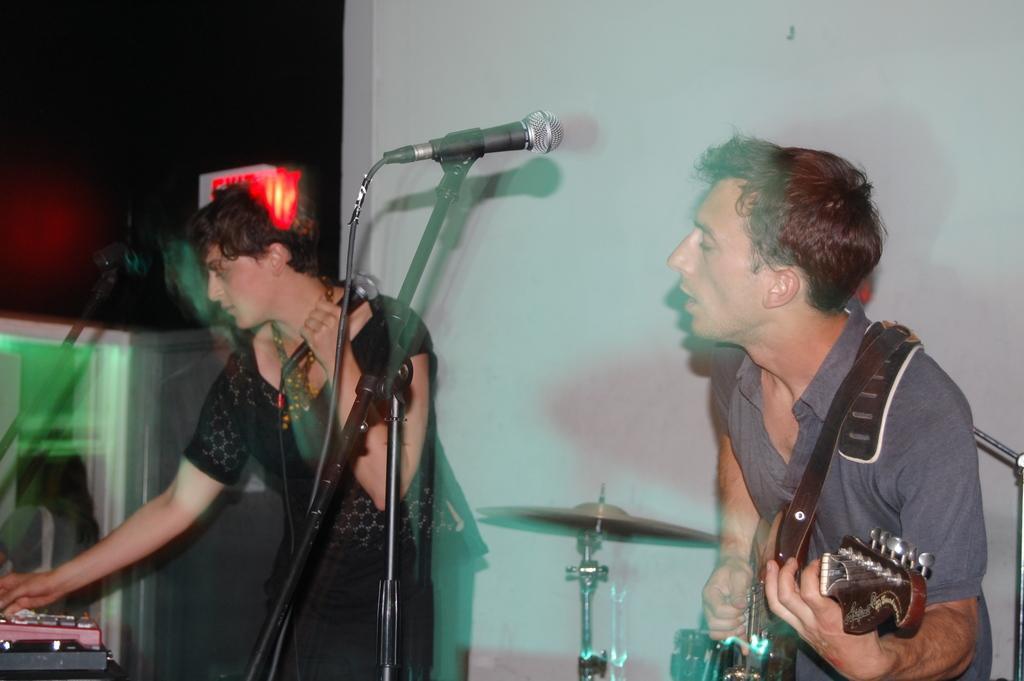How would you summarize this image in a sentence or two? In the image we can see there are two people. Right side one is holding a guitar in his hand and left side one is holding microphone. This is a musical band. This is a cable wire. 